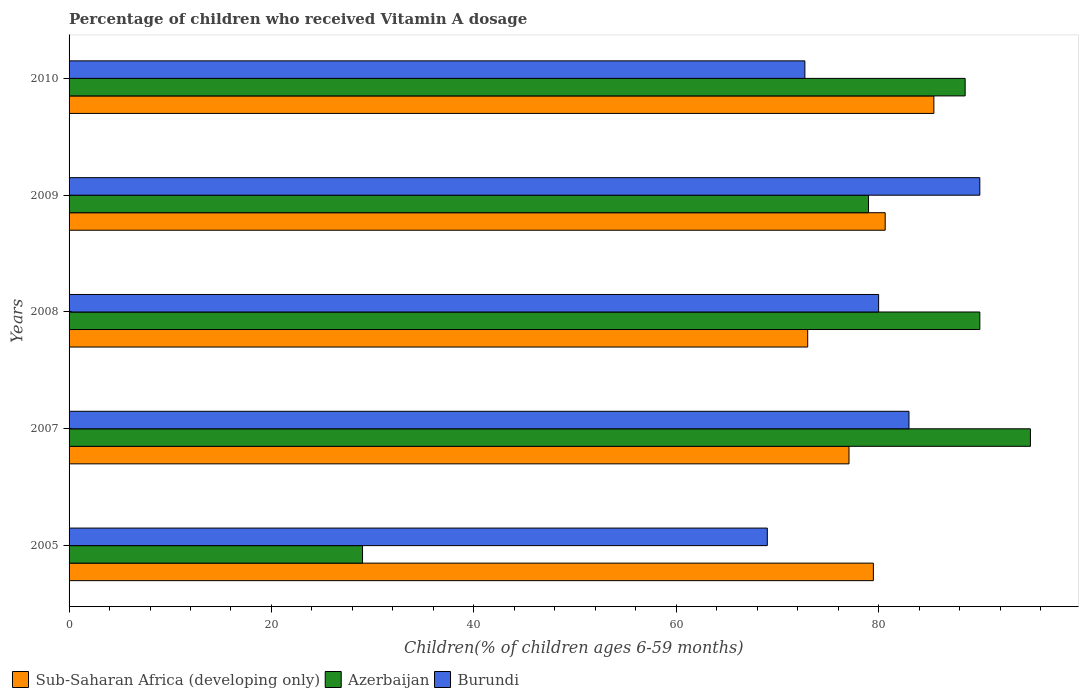How many different coloured bars are there?
Make the answer very short. 3. Are the number of bars per tick equal to the number of legend labels?
Your response must be concise. Yes. How many bars are there on the 1st tick from the top?
Provide a short and direct response. 3. How many bars are there on the 5th tick from the bottom?
Keep it short and to the point. 3. What is the label of the 4th group of bars from the top?
Your response must be concise. 2007. In how many cases, is the number of bars for a given year not equal to the number of legend labels?
Offer a terse response. 0. In which year was the percentage of children who received Vitamin A dosage in Azerbaijan maximum?
Ensure brevity in your answer.  2007. What is the total percentage of children who received Vitamin A dosage in Azerbaijan in the graph?
Provide a short and direct response. 381.55. What is the difference between the percentage of children who received Vitamin A dosage in Sub-Saharan Africa (developing only) in 2007 and that in 2008?
Give a very brief answer. 4.08. What is the difference between the percentage of children who received Vitamin A dosage in Sub-Saharan Africa (developing only) in 2008 and the percentage of children who received Vitamin A dosage in Burundi in 2007?
Keep it short and to the point. -10.01. What is the average percentage of children who received Vitamin A dosage in Sub-Saharan Africa (developing only) per year?
Your answer should be compact. 79.13. In the year 2010, what is the difference between the percentage of children who received Vitamin A dosage in Azerbaijan and percentage of children who received Vitamin A dosage in Burundi?
Provide a succinct answer. 15.84. What is the ratio of the percentage of children who received Vitamin A dosage in Burundi in 2007 to that in 2010?
Ensure brevity in your answer.  1.14. Is the difference between the percentage of children who received Vitamin A dosage in Azerbaijan in 2008 and 2010 greater than the difference between the percentage of children who received Vitamin A dosage in Burundi in 2008 and 2010?
Offer a terse response. No. What is the difference between the highest and the second highest percentage of children who received Vitamin A dosage in Azerbaijan?
Make the answer very short. 5. In how many years, is the percentage of children who received Vitamin A dosage in Burundi greater than the average percentage of children who received Vitamin A dosage in Burundi taken over all years?
Give a very brief answer. 3. Is the sum of the percentage of children who received Vitamin A dosage in Azerbaijan in 2007 and 2010 greater than the maximum percentage of children who received Vitamin A dosage in Burundi across all years?
Provide a short and direct response. Yes. What does the 3rd bar from the top in 2010 represents?
Keep it short and to the point. Sub-Saharan Africa (developing only). What does the 1st bar from the bottom in 2005 represents?
Provide a succinct answer. Sub-Saharan Africa (developing only). What is the difference between two consecutive major ticks on the X-axis?
Offer a terse response. 20. Are the values on the major ticks of X-axis written in scientific E-notation?
Offer a very short reply. No. Where does the legend appear in the graph?
Provide a short and direct response. Bottom left. How many legend labels are there?
Give a very brief answer. 3. How are the legend labels stacked?
Make the answer very short. Horizontal. What is the title of the graph?
Your answer should be very brief. Percentage of children who received Vitamin A dosage. What is the label or title of the X-axis?
Offer a very short reply. Children(% of children ages 6-59 months). What is the label or title of the Y-axis?
Give a very brief answer. Years. What is the Children(% of children ages 6-59 months) of Sub-Saharan Africa (developing only) in 2005?
Give a very brief answer. 79.48. What is the Children(% of children ages 6-59 months) of Azerbaijan in 2005?
Keep it short and to the point. 29. What is the Children(% of children ages 6-59 months) of Burundi in 2005?
Make the answer very short. 69. What is the Children(% of children ages 6-59 months) of Sub-Saharan Africa (developing only) in 2007?
Your response must be concise. 77.07. What is the Children(% of children ages 6-59 months) of Burundi in 2007?
Provide a short and direct response. 83. What is the Children(% of children ages 6-59 months) in Sub-Saharan Africa (developing only) in 2008?
Ensure brevity in your answer.  72.99. What is the Children(% of children ages 6-59 months) of Azerbaijan in 2008?
Your answer should be very brief. 90. What is the Children(% of children ages 6-59 months) of Burundi in 2008?
Give a very brief answer. 80. What is the Children(% of children ages 6-59 months) of Sub-Saharan Africa (developing only) in 2009?
Ensure brevity in your answer.  80.65. What is the Children(% of children ages 6-59 months) of Azerbaijan in 2009?
Offer a very short reply. 79. What is the Children(% of children ages 6-59 months) of Burundi in 2009?
Your answer should be compact. 90. What is the Children(% of children ages 6-59 months) of Sub-Saharan Africa (developing only) in 2010?
Ensure brevity in your answer.  85.46. What is the Children(% of children ages 6-59 months) in Azerbaijan in 2010?
Your response must be concise. 88.55. What is the Children(% of children ages 6-59 months) of Burundi in 2010?
Provide a short and direct response. 72.71. Across all years, what is the maximum Children(% of children ages 6-59 months) of Sub-Saharan Africa (developing only)?
Give a very brief answer. 85.46. Across all years, what is the maximum Children(% of children ages 6-59 months) in Burundi?
Give a very brief answer. 90. Across all years, what is the minimum Children(% of children ages 6-59 months) of Sub-Saharan Africa (developing only)?
Offer a very short reply. 72.99. Across all years, what is the minimum Children(% of children ages 6-59 months) in Azerbaijan?
Offer a very short reply. 29. Across all years, what is the minimum Children(% of children ages 6-59 months) of Burundi?
Your response must be concise. 69. What is the total Children(% of children ages 6-59 months) in Sub-Saharan Africa (developing only) in the graph?
Offer a very short reply. 395.65. What is the total Children(% of children ages 6-59 months) of Azerbaijan in the graph?
Provide a short and direct response. 381.55. What is the total Children(% of children ages 6-59 months) of Burundi in the graph?
Your answer should be very brief. 394.71. What is the difference between the Children(% of children ages 6-59 months) in Sub-Saharan Africa (developing only) in 2005 and that in 2007?
Keep it short and to the point. 2.41. What is the difference between the Children(% of children ages 6-59 months) of Azerbaijan in 2005 and that in 2007?
Keep it short and to the point. -66. What is the difference between the Children(% of children ages 6-59 months) in Sub-Saharan Africa (developing only) in 2005 and that in 2008?
Offer a terse response. 6.49. What is the difference between the Children(% of children ages 6-59 months) in Azerbaijan in 2005 and that in 2008?
Give a very brief answer. -61. What is the difference between the Children(% of children ages 6-59 months) of Burundi in 2005 and that in 2008?
Give a very brief answer. -11. What is the difference between the Children(% of children ages 6-59 months) of Sub-Saharan Africa (developing only) in 2005 and that in 2009?
Your answer should be very brief. -1.17. What is the difference between the Children(% of children ages 6-59 months) of Sub-Saharan Africa (developing only) in 2005 and that in 2010?
Provide a succinct answer. -5.98. What is the difference between the Children(% of children ages 6-59 months) in Azerbaijan in 2005 and that in 2010?
Offer a terse response. -59.55. What is the difference between the Children(% of children ages 6-59 months) of Burundi in 2005 and that in 2010?
Offer a very short reply. -3.71. What is the difference between the Children(% of children ages 6-59 months) in Sub-Saharan Africa (developing only) in 2007 and that in 2008?
Provide a succinct answer. 4.08. What is the difference between the Children(% of children ages 6-59 months) in Sub-Saharan Africa (developing only) in 2007 and that in 2009?
Your answer should be very brief. -3.58. What is the difference between the Children(% of children ages 6-59 months) of Burundi in 2007 and that in 2009?
Your answer should be very brief. -7. What is the difference between the Children(% of children ages 6-59 months) in Sub-Saharan Africa (developing only) in 2007 and that in 2010?
Your response must be concise. -8.39. What is the difference between the Children(% of children ages 6-59 months) of Azerbaijan in 2007 and that in 2010?
Ensure brevity in your answer.  6.45. What is the difference between the Children(% of children ages 6-59 months) of Burundi in 2007 and that in 2010?
Provide a succinct answer. 10.29. What is the difference between the Children(% of children ages 6-59 months) in Sub-Saharan Africa (developing only) in 2008 and that in 2009?
Your response must be concise. -7.66. What is the difference between the Children(% of children ages 6-59 months) of Sub-Saharan Africa (developing only) in 2008 and that in 2010?
Your answer should be very brief. -12.47. What is the difference between the Children(% of children ages 6-59 months) of Azerbaijan in 2008 and that in 2010?
Your answer should be compact. 1.45. What is the difference between the Children(% of children ages 6-59 months) in Burundi in 2008 and that in 2010?
Make the answer very short. 7.29. What is the difference between the Children(% of children ages 6-59 months) of Sub-Saharan Africa (developing only) in 2009 and that in 2010?
Your answer should be compact. -4.81. What is the difference between the Children(% of children ages 6-59 months) of Azerbaijan in 2009 and that in 2010?
Ensure brevity in your answer.  -9.55. What is the difference between the Children(% of children ages 6-59 months) of Burundi in 2009 and that in 2010?
Give a very brief answer. 17.29. What is the difference between the Children(% of children ages 6-59 months) of Sub-Saharan Africa (developing only) in 2005 and the Children(% of children ages 6-59 months) of Azerbaijan in 2007?
Ensure brevity in your answer.  -15.52. What is the difference between the Children(% of children ages 6-59 months) of Sub-Saharan Africa (developing only) in 2005 and the Children(% of children ages 6-59 months) of Burundi in 2007?
Your answer should be compact. -3.52. What is the difference between the Children(% of children ages 6-59 months) of Azerbaijan in 2005 and the Children(% of children ages 6-59 months) of Burundi in 2007?
Provide a succinct answer. -54. What is the difference between the Children(% of children ages 6-59 months) of Sub-Saharan Africa (developing only) in 2005 and the Children(% of children ages 6-59 months) of Azerbaijan in 2008?
Give a very brief answer. -10.52. What is the difference between the Children(% of children ages 6-59 months) of Sub-Saharan Africa (developing only) in 2005 and the Children(% of children ages 6-59 months) of Burundi in 2008?
Ensure brevity in your answer.  -0.52. What is the difference between the Children(% of children ages 6-59 months) of Azerbaijan in 2005 and the Children(% of children ages 6-59 months) of Burundi in 2008?
Give a very brief answer. -51. What is the difference between the Children(% of children ages 6-59 months) of Sub-Saharan Africa (developing only) in 2005 and the Children(% of children ages 6-59 months) of Azerbaijan in 2009?
Give a very brief answer. 0.48. What is the difference between the Children(% of children ages 6-59 months) of Sub-Saharan Africa (developing only) in 2005 and the Children(% of children ages 6-59 months) of Burundi in 2009?
Make the answer very short. -10.52. What is the difference between the Children(% of children ages 6-59 months) of Azerbaijan in 2005 and the Children(% of children ages 6-59 months) of Burundi in 2009?
Ensure brevity in your answer.  -61. What is the difference between the Children(% of children ages 6-59 months) of Sub-Saharan Africa (developing only) in 2005 and the Children(% of children ages 6-59 months) of Azerbaijan in 2010?
Make the answer very short. -9.07. What is the difference between the Children(% of children ages 6-59 months) of Sub-Saharan Africa (developing only) in 2005 and the Children(% of children ages 6-59 months) of Burundi in 2010?
Your answer should be very brief. 6.77. What is the difference between the Children(% of children ages 6-59 months) of Azerbaijan in 2005 and the Children(% of children ages 6-59 months) of Burundi in 2010?
Your answer should be very brief. -43.71. What is the difference between the Children(% of children ages 6-59 months) of Sub-Saharan Africa (developing only) in 2007 and the Children(% of children ages 6-59 months) of Azerbaijan in 2008?
Keep it short and to the point. -12.93. What is the difference between the Children(% of children ages 6-59 months) in Sub-Saharan Africa (developing only) in 2007 and the Children(% of children ages 6-59 months) in Burundi in 2008?
Your answer should be very brief. -2.93. What is the difference between the Children(% of children ages 6-59 months) of Sub-Saharan Africa (developing only) in 2007 and the Children(% of children ages 6-59 months) of Azerbaijan in 2009?
Give a very brief answer. -1.93. What is the difference between the Children(% of children ages 6-59 months) of Sub-Saharan Africa (developing only) in 2007 and the Children(% of children ages 6-59 months) of Burundi in 2009?
Give a very brief answer. -12.93. What is the difference between the Children(% of children ages 6-59 months) of Azerbaijan in 2007 and the Children(% of children ages 6-59 months) of Burundi in 2009?
Provide a succinct answer. 5. What is the difference between the Children(% of children ages 6-59 months) in Sub-Saharan Africa (developing only) in 2007 and the Children(% of children ages 6-59 months) in Azerbaijan in 2010?
Provide a succinct answer. -11.48. What is the difference between the Children(% of children ages 6-59 months) in Sub-Saharan Africa (developing only) in 2007 and the Children(% of children ages 6-59 months) in Burundi in 2010?
Your response must be concise. 4.36. What is the difference between the Children(% of children ages 6-59 months) of Azerbaijan in 2007 and the Children(% of children ages 6-59 months) of Burundi in 2010?
Give a very brief answer. 22.29. What is the difference between the Children(% of children ages 6-59 months) in Sub-Saharan Africa (developing only) in 2008 and the Children(% of children ages 6-59 months) in Azerbaijan in 2009?
Keep it short and to the point. -6.01. What is the difference between the Children(% of children ages 6-59 months) of Sub-Saharan Africa (developing only) in 2008 and the Children(% of children ages 6-59 months) of Burundi in 2009?
Make the answer very short. -17.01. What is the difference between the Children(% of children ages 6-59 months) in Sub-Saharan Africa (developing only) in 2008 and the Children(% of children ages 6-59 months) in Azerbaijan in 2010?
Offer a very short reply. -15.56. What is the difference between the Children(% of children ages 6-59 months) of Sub-Saharan Africa (developing only) in 2008 and the Children(% of children ages 6-59 months) of Burundi in 2010?
Offer a terse response. 0.28. What is the difference between the Children(% of children ages 6-59 months) in Azerbaijan in 2008 and the Children(% of children ages 6-59 months) in Burundi in 2010?
Provide a short and direct response. 17.29. What is the difference between the Children(% of children ages 6-59 months) of Sub-Saharan Africa (developing only) in 2009 and the Children(% of children ages 6-59 months) of Azerbaijan in 2010?
Provide a short and direct response. -7.9. What is the difference between the Children(% of children ages 6-59 months) in Sub-Saharan Africa (developing only) in 2009 and the Children(% of children ages 6-59 months) in Burundi in 2010?
Offer a very short reply. 7.94. What is the difference between the Children(% of children ages 6-59 months) of Azerbaijan in 2009 and the Children(% of children ages 6-59 months) of Burundi in 2010?
Offer a very short reply. 6.29. What is the average Children(% of children ages 6-59 months) in Sub-Saharan Africa (developing only) per year?
Give a very brief answer. 79.13. What is the average Children(% of children ages 6-59 months) of Azerbaijan per year?
Your answer should be very brief. 76.31. What is the average Children(% of children ages 6-59 months) in Burundi per year?
Offer a terse response. 78.94. In the year 2005, what is the difference between the Children(% of children ages 6-59 months) in Sub-Saharan Africa (developing only) and Children(% of children ages 6-59 months) in Azerbaijan?
Give a very brief answer. 50.48. In the year 2005, what is the difference between the Children(% of children ages 6-59 months) of Sub-Saharan Africa (developing only) and Children(% of children ages 6-59 months) of Burundi?
Offer a very short reply. 10.48. In the year 2007, what is the difference between the Children(% of children ages 6-59 months) in Sub-Saharan Africa (developing only) and Children(% of children ages 6-59 months) in Azerbaijan?
Provide a short and direct response. -17.93. In the year 2007, what is the difference between the Children(% of children ages 6-59 months) in Sub-Saharan Africa (developing only) and Children(% of children ages 6-59 months) in Burundi?
Offer a terse response. -5.93. In the year 2008, what is the difference between the Children(% of children ages 6-59 months) of Sub-Saharan Africa (developing only) and Children(% of children ages 6-59 months) of Azerbaijan?
Your answer should be compact. -17.01. In the year 2008, what is the difference between the Children(% of children ages 6-59 months) of Sub-Saharan Africa (developing only) and Children(% of children ages 6-59 months) of Burundi?
Make the answer very short. -7.01. In the year 2008, what is the difference between the Children(% of children ages 6-59 months) of Azerbaijan and Children(% of children ages 6-59 months) of Burundi?
Provide a succinct answer. 10. In the year 2009, what is the difference between the Children(% of children ages 6-59 months) in Sub-Saharan Africa (developing only) and Children(% of children ages 6-59 months) in Azerbaijan?
Keep it short and to the point. 1.65. In the year 2009, what is the difference between the Children(% of children ages 6-59 months) in Sub-Saharan Africa (developing only) and Children(% of children ages 6-59 months) in Burundi?
Ensure brevity in your answer.  -9.35. In the year 2009, what is the difference between the Children(% of children ages 6-59 months) in Azerbaijan and Children(% of children ages 6-59 months) in Burundi?
Keep it short and to the point. -11. In the year 2010, what is the difference between the Children(% of children ages 6-59 months) of Sub-Saharan Africa (developing only) and Children(% of children ages 6-59 months) of Azerbaijan?
Offer a terse response. -3.09. In the year 2010, what is the difference between the Children(% of children ages 6-59 months) of Sub-Saharan Africa (developing only) and Children(% of children ages 6-59 months) of Burundi?
Keep it short and to the point. 12.75. In the year 2010, what is the difference between the Children(% of children ages 6-59 months) in Azerbaijan and Children(% of children ages 6-59 months) in Burundi?
Offer a very short reply. 15.84. What is the ratio of the Children(% of children ages 6-59 months) of Sub-Saharan Africa (developing only) in 2005 to that in 2007?
Your response must be concise. 1.03. What is the ratio of the Children(% of children ages 6-59 months) of Azerbaijan in 2005 to that in 2007?
Your response must be concise. 0.31. What is the ratio of the Children(% of children ages 6-59 months) in Burundi in 2005 to that in 2007?
Offer a very short reply. 0.83. What is the ratio of the Children(% of children ages 6-59 months) of Sub-Saharan Africa (developing only) in 2005 to that in 2008?
Your answer should be very brief. 1.09. What is the ratio of the Children(% of children ages 6-59 months) in Azerbaijan in 2005 to that in 2008?
Provide a succinct answer. 0.32. What is the ratio of the Children(% of children ages 6-59 months) in Burundi in 2005 to that in 2008?
Make the answer very short. 0.86. What is the ratio of the Children(% of children ages 6-59 months) in Sub-Saharan Africa (developing only) in 2005 to that in 2009?
Your answer should be very brief. 0.99. What is the ratio of the Children(% of children ages 6-59 months) of Azerbaijan in 2005 to that in 2009?
Provide a short and direct response. 0.37. What is the ratio of the Children(% of children ages 6-59 months) of Burundi in 2005 to that in 2009?
Your response must be concise. 0.77. What is the ratio of the Children(% of children ages 6-59 months) in Azerbaijan in 2005 to that in 2010?
Make the answer very short. 0.33. What is the ratio of the Children(% of children ages 6-59 months) in Burundi in 2005 to that in 2010?
Your answer should be compact. 0.95. What is the ratio of the Children(% of children ages 6-59 months) of Sub-Saharan Africa (developing only) in 2007 to that in 2008?
Give a very brief answer. 1.06. What is the ratio of the Children(% of children ages 6-59 months) in Azerbaijan in 2007 to that in 2008?
Make the answer very short. 1.06. What is the ratio of the Children(% of children ages 6-59 months) in Burundi in 2007 to that in 2008?
Your answer should be very brief. 1.04. What is the ratio of the Children(% of children ages 6-59 months) in Sub-Saharan Africa (developing only) in 2007 to that in 2009?
Give a very brief answer. 0.96. What is the ratio of the Children(% of children ages 6-59 months) in Azerbaijan in 2007 to that in 2009?
Give a very brief answer. 1.2. What is the ratio of the Children(% of children ages 6-59 months) in Burundi in 2007 to that in 2009?
Your answer should be compact. 0.92. What is the ratio of the Children(% of children ages 6-59 months) of Sub-Saharan Africa (developing only) in 2007 to that in 2010?
Your answer should be very brief. 0.9. What is the ratio of the Children(% of children ages 6-59 months) in Azerbaijan in 2007 to that in 2010?
Give a very brief answer. 1.07. What is the ratio of the Children(% of children ages 6-59 months) in Burundi in 2007 to that in 2010?
Provide a short and direct response. 1.14. What is the ratio of the Children(% of children ages 6-59 months) of Sub-Saharan Africa (developing only) in 2008 to that in 2009?
Offer a very short reply. 0.91. What is the ratio of the Children(% of children ages 6-59 months) in Azerbaijan in 2008 to that in 2009?
Provide a succinct answer. 1.14. What is the ratio of the Children(% of children ages 6-59 months) of Burundi in 2008 to that in 2009?
Provide a succinct answer. 0.89. What is the ratio of the Children(% of children ages 6-59 months) in Sub-Saharan Africa (developing only) in 2008 to that in 2010?
Keep it short and to the point. 0.85. What is the ratio of the Children(% of children ages 6-59 months) in Azerbaijan in 2008 to that in 2010?
Offer a very short reply. 1.02. What is the ratio of the Children(% of children ages 6-59 months) in Burundi in 2008 to that in 2010?
Your answer should be compact. 1.1. What is the ratio of the Children(% of children ages 6-59 months) in Sub-Saharan Africa (developing only) in 2009 to that in 2010?
Your answer should be very brief. 0.94. What is the ratio of the Children(% of children ages 6-59 months) of Azerbaijan in 2009 to that in 2010?
Offer a terse response. 0.89. What is the ratio of the Children(% of children ages 6-59 months) in Burundi in 2009 to that in 2010?
Give a very brief answer. 1.24. What is the difference between the highest and the second highest Children(% of children ages 6-59 months) in Sub-Saharan Africa (developing only)?
Your response must be concise. 4.81. What is the difference between the highest and the second highest Children(% of children ages 6-59 months) in Burundi?
Your response must be concise. 7. What is the difference between the highest and the lowest Children(% of children ages 6-59 months) of Sub-Saharan Africa (developing only)?
Provide a short and direct response. 12.47. What is the difference between the highest and the lowest Children(% of children ages 6-59 months) in Azerbaijan?
Make the answer very short. 66. 